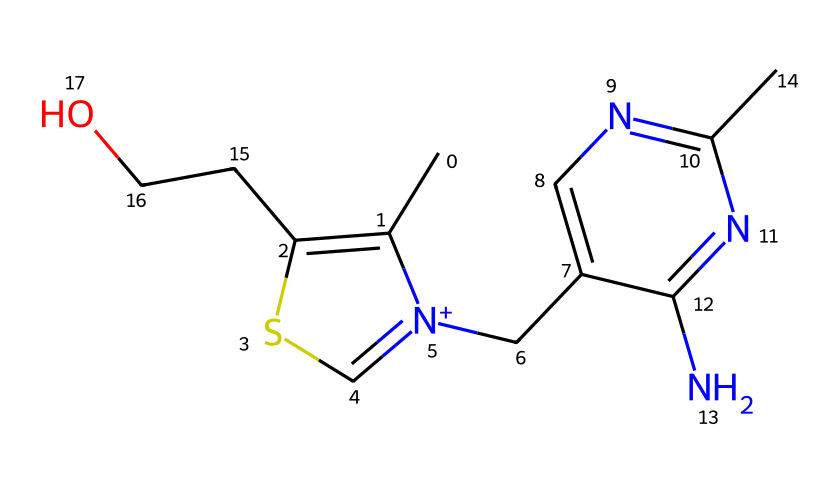what is the main functional group present in thiamine? The structure contains a sulfur atom connected by a single bond to the carbon chain, characteristic of organosulfur compounds. The presence of the sulfur atom indicates that the main functional group is a thiazole ring, which is common in thiamine.
Answer: thiazole how many nitrogen atoms are in thiamine? By analyzing the SMILES representation, the structure shows two nitrogen atoms present in the form of the amine groups, which are visible in the cyclic and linear portions of the structure.
Answer: two what type of chemical compound is thiamine classified as? Thiamine has notable characteristics that define it as a vitamin, specifically a B-vitamin. It is crucial for cognitive functions and relates to metabolic processes in the body.
Answer: vitamin how many rings are present in the thiamine structure? Upon inspecting the structure, it contains two rings: one is a thiazole ring, and the other is a pyrimidine ring, indicating it has a bicyclic structure.
Answer: two what does the presence of sulfur in thiamine imply about its properties? The presence of sulfur typically suggests reactivity, particularly in redox reactions, and indicates that thiamine can participate in biochemical processes essential for energy metabolism.
Answer: reactivity 